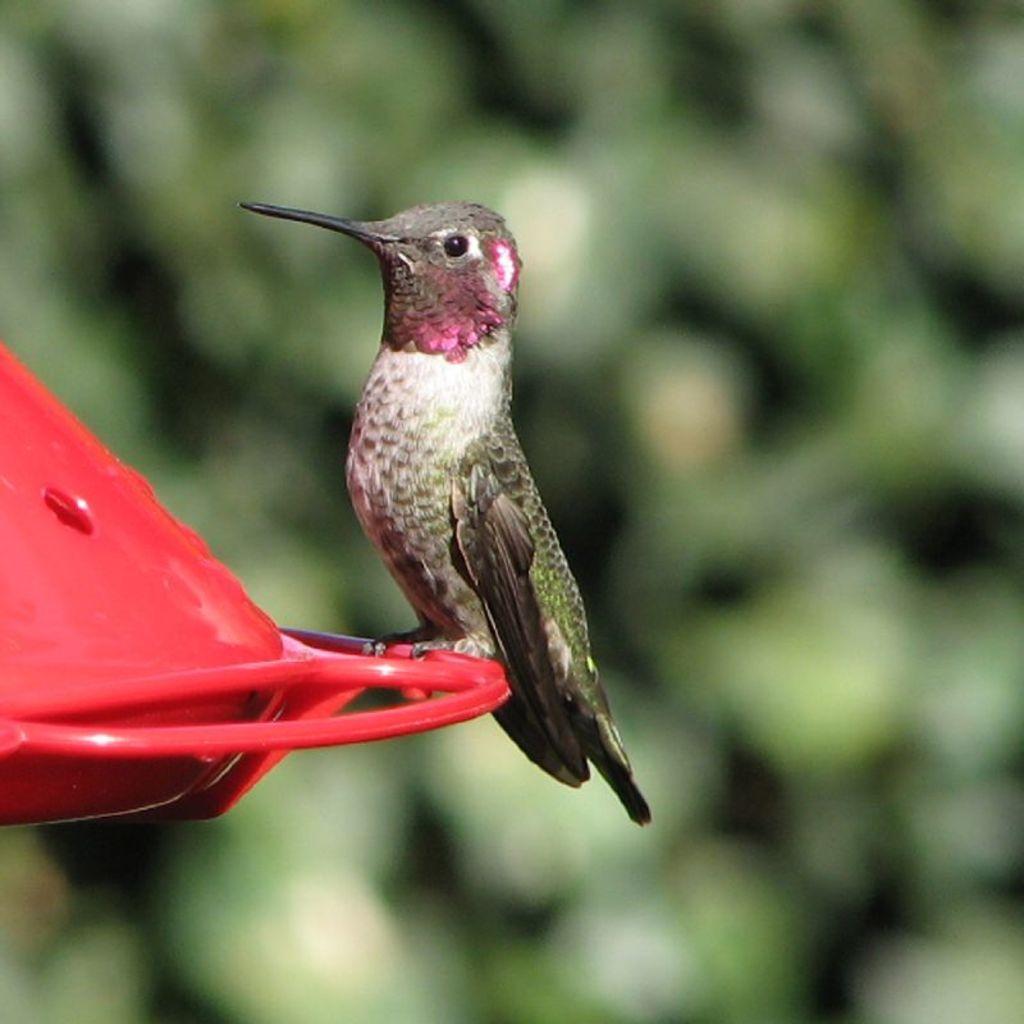Describe this image in one or two sentences. In this image there is a bird on the object. The background is blurry. 